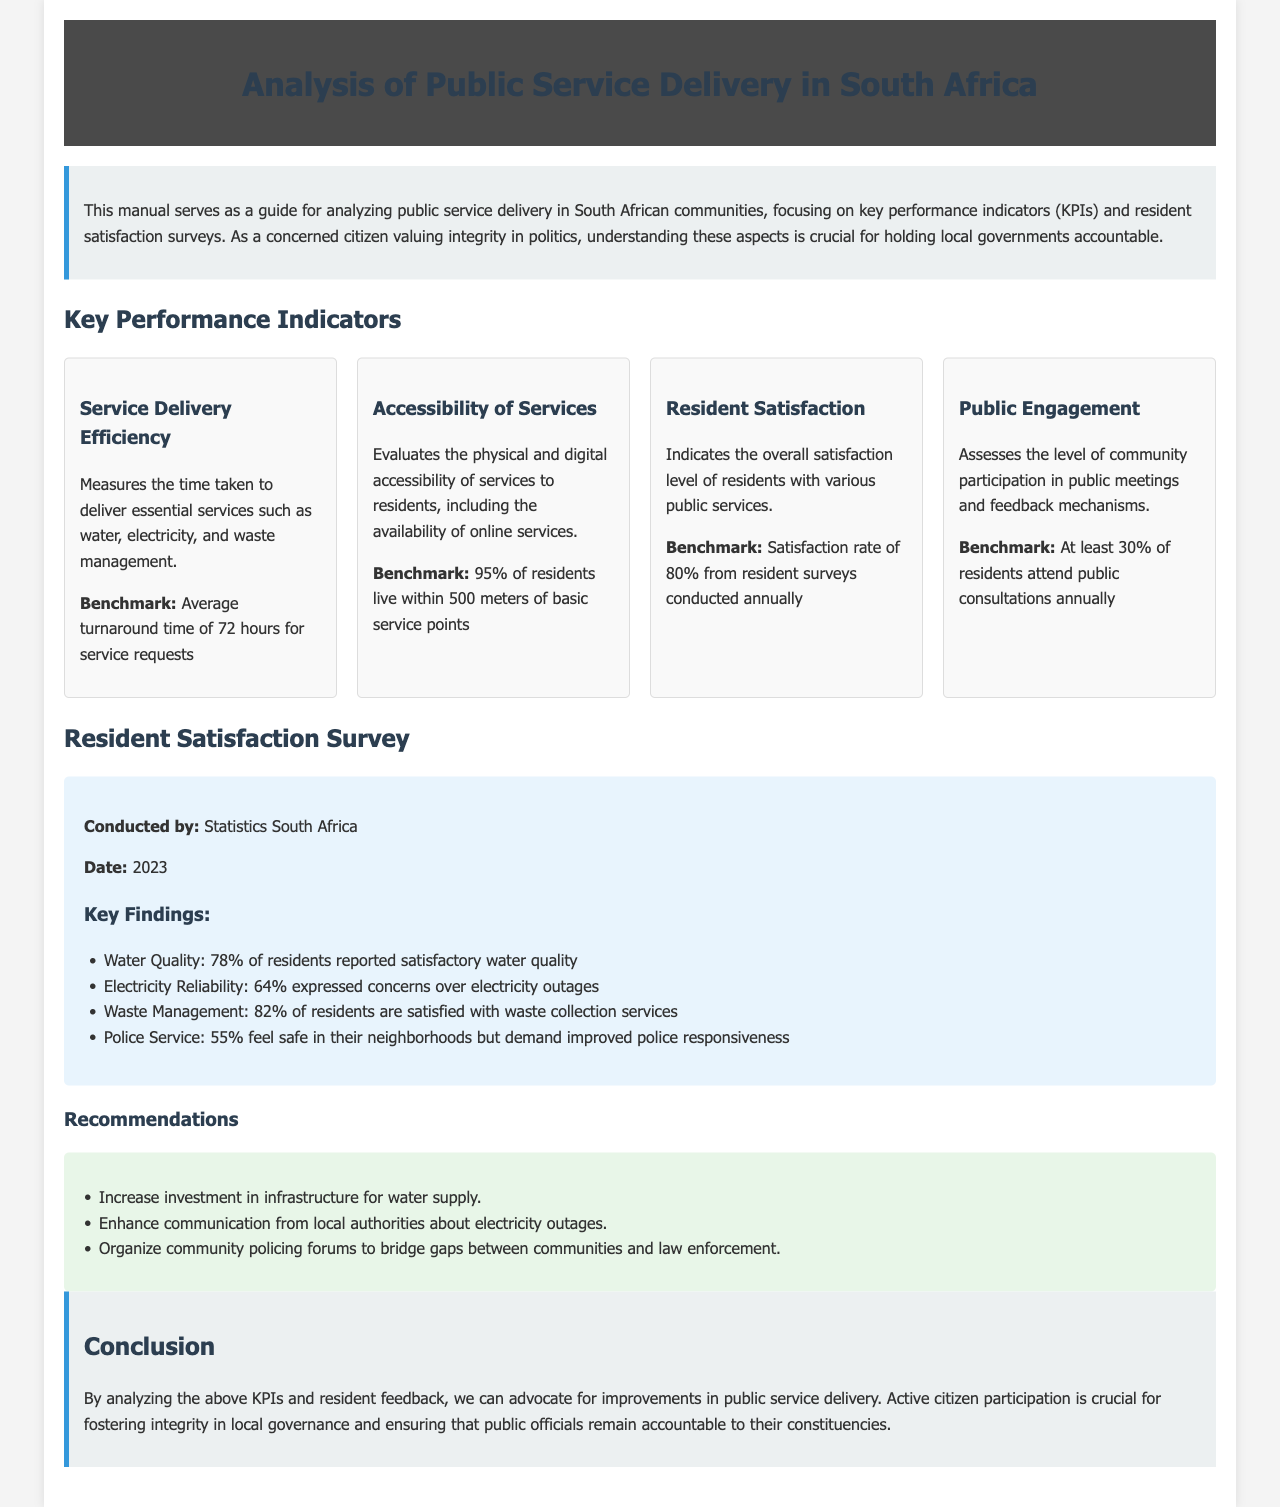What is the title of the document? The title of the document is provided in the header section and indicates the main topic of analysis.
Answer: Analysis of Public Service Delivery in South Africa What is the benchmark for Service Delivery Efficiency? The benchmark for Service Delivery Efficiency is specified in the KPI section for efficiency measures.
Answer: Average turnaround time of 72 hours for service requests Which organization conducted the Resident Satisfaction Survey? The document specifies which organization performed the survey by mentioning it in the survey results section.
Answer: Statistics South Africa What percentage of residents are satisfied with waste collection services? This percentage is listed in the key findings of the resident satisfaction survey, indicating public opinion on waste services.
Answer: 82% What is the satisfaction rate benchmark for Resident Satisfaction? This benchmark is provided in the KPIs section related to resident satisfaction levels.
Answer: Satisfaction rate of 80% from resident surveys conducted annually How many recommendations are provided in the document? This information can be gathered by counting the bullet points in the recommendations section.
Answer: Three What percentage of residents reported satisfactory water quality? The document includes specific resident feedback regarding water quality in the survey results section.
Answer: 78% What is the benchmark for the Accessibility of Services? The benchmark for Accessibility of Services is stated in the relevant KPI section of the document.
Answer: 95% of residents live within 500 meters of basic service points How many percent of residents feel safe in their neighborhoods according to the survey? This information is relayed in the key findings of the survey regarding safety perceptions.
Answer: 55% 